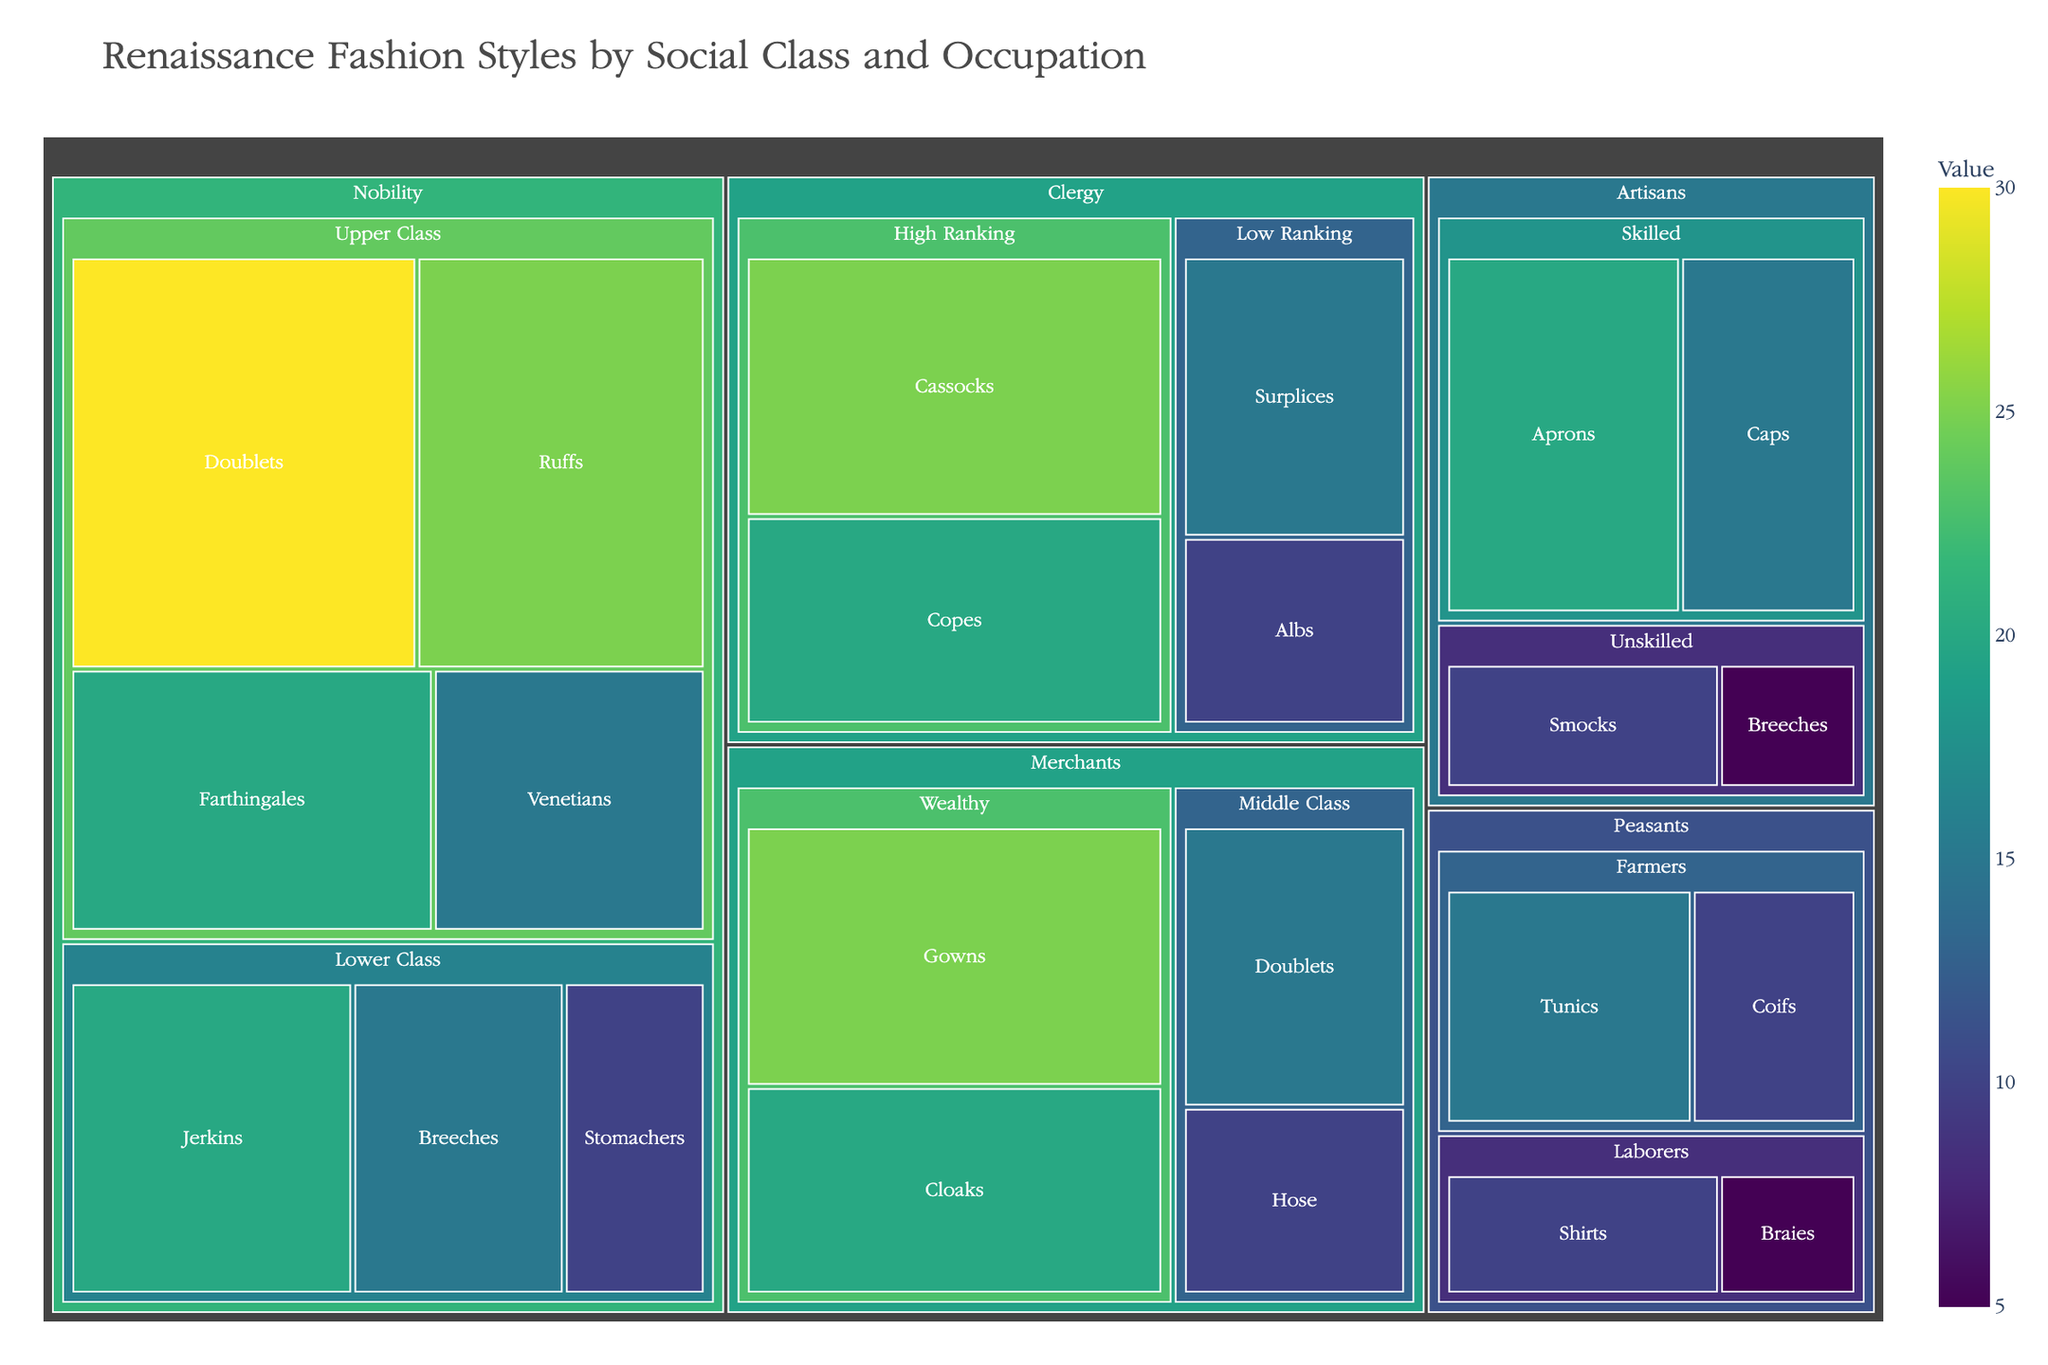What's the title of the figure? The title of the figure is displayed at the top and usually in a larger and different font to stand out.
Answer: Renaissance Fashion Styles by Social Class and Occupation What color scheme is used in the figure? The color scheme used to represent the values is displayed as a gradient on the figure. The code specifies a 'Viridis' color scale, which is typically a spectrum from dark purple to yellow.
Answer: Viridis Which item has the highest value in the figure? By examining the treemap, look for the item with the largest area. The largest box represents the item with the highest value.
Answer: Doublets (Upper Class Nobility, Value 30) Which category has the lowest sum of values? Sum the values for each main category: Nobility (30+25+20+15+20+15+10=135), Clergy (25+20+15+10=70), Merchants (25+20+15+10=70), Artisans (20+15+10+5=50), Peasants (15+10+10+5=40). Artisans have the lowest sum.
Answer: Peasants How does the value of 'Caps' among Artisans compare to 'Cloaks' among Merchants? Compare the values by finding the respective subcategories and items. Caps under Skilled Artisans have 15, while Cloaks under Wealthy Merchants have 20.
Answer: Cloaks have a higher value What is the sum of the values for High Ranking Clergy items? Add the values for Cassocks and Copes in the High Ranking Clergy subcategory. 25 (Cassocks) + 20 (Copes) = 45.
Answer: 45 How many items are there for Merchants? Count all the unique items listed under the Merchants category in the treemap. The items are Gowns, Cloaks, Doublets, and Hose.
Answer: 4 items Compare the value of 'Stomachers' in Lower Class Nobility to the value of 'Surplices' in Low Ranking Clergy. Which is higher? Look for Stomachers and Surplices in their respective subcategories. Stomachers have a value of 10, while Surplices also have a value of 15.
Answer: Surplices are higher Which subcategory within Nobility has the highest total value? Sum the values within each Nobility subcategory: Upper Class (30 + 25 + 20 + 15 = 90) and Lower Class (20 + 15 + 10 = 45). Upper Class has the highest total value.
Answer: Upper Class What is the value ratio of 'Breeches' in Lower Class Nobility to 'Doublets' in Middle Class Merchants? Compare the values of Breeches (Lower Class Nobility) which is 15 and Doublets (Middle Class Merchants) which is also 15. The ratio is 15/15 = 1.
Answer: 1 